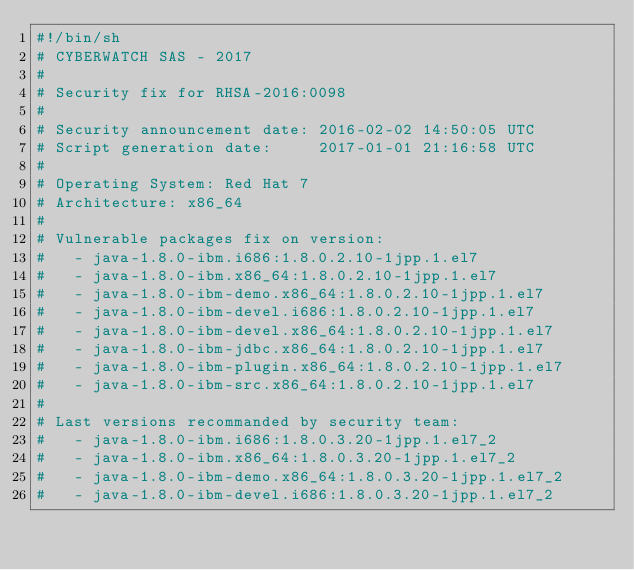Convert code to text. <code><loc_0><loc_0><loc_500><loc_500><_Bash_>#!/bin/sh
# CYBERWATCH SAS - 2017
#
# Security fix for RHSA-2016:0098
#
# Security announcement date: 2016-02-02 14:50:05 UTC
# Script generation date:     2017-01-01 21:16:58 UTC
#
# Operating System: Red Hat 7
# Architecture: x86_64
#
# Vulnerable packages fix on version:
#   - java-1.8.0-ibm.i686:1.8.0.2.10-1jpp.1.el7
#   - java-1.8.0-ibm.x86_64:1.8.0.2.10-1jpp.1.el7
#   - java-1.8.0-ibm-demo.x86_64:1.8.0.2.10-1jpp.1.el7
#   - java-1.8.0-ibm-devel.i686:1.8.0.2.10-1jpp.1.el7
#   - java-1.8.0-ibm-devel.x86_64:1.8.0.2.10-1jpp.1.el7
#   - java-1.8.0-ibm-jdbc.x86_64:1.8.0.2.10-1jpp.1.el7
#   - java-1.8.0-ibm-plugin.x86_64:1.8.0.2.10-1jpp.1.el7
#   - java-1.8.0-ibm-src.x86_64:1.8.0.2.10-1jpp.1.el7
#
# Last versions recommanded by security team:
#   - java-1.8.0-ibm.i686:1.8.0.3.20-1jpp.1.el7_2
#   - java-1.8.0-ibm.x86_64:1.8.0.3.20-1jpp.1.el7_2
#   - java-1.8.0-ibm-demo.x86_64:1.8.0.3.20-1jpp.1.el7_2
#   - java-1.8.0-ibm-devel.i686:1.8.0.3.20-1jpp.1.el7_2</code> 